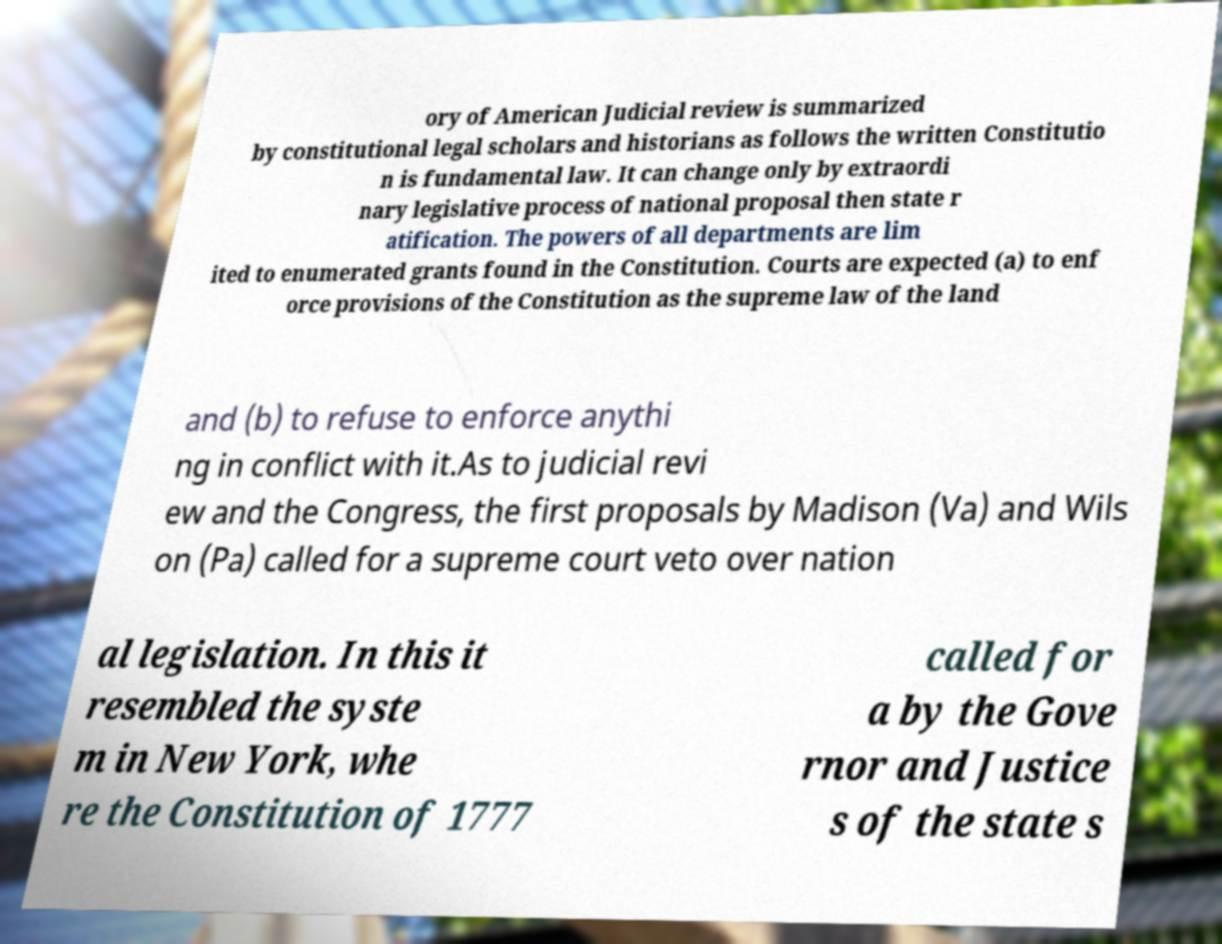Could you assist in decoding the text presented in this image and type it out clearly? ory of American Judicial review is summarized by constitutional legal scholars and historians as follows the written Constitutio n is fundamental law. It can change only by extraordi nary legislative process of national proposal then state r atification. The powers of all departments are lim ited to enumerated grants found in the Constitution. Courts are expected (a) to enf orce provisions of the Constitution as the supreme law of the land and (b) to refuse to enforce anythi ng in conflict with it.As to judicial revi ew and the Congress, the first proposals by Madison (Va) and Wils on (Pa) called for a supreme court veto over nation al legislation. In this it resembled the syste m in New York, whe re the Constitution of 1777 called for a by the Gove rnor and Justice s of the state s 